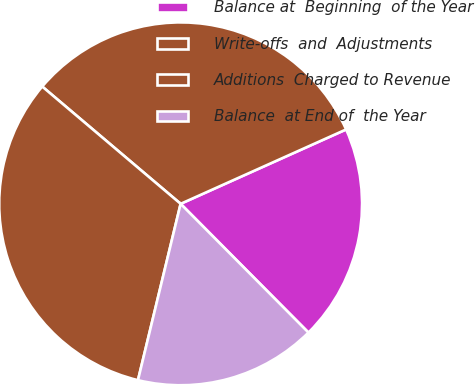Convert chart. <chart><loc_0><loc_0><loc_500><loc_500><pie_chart><fcel>Balance at  Beginning  of the Year<fcel>Write-offs  and  Adjustments<fcel>Additions  Charged to Revenue<fcel>Balance  at End of  the Year<nl><fcel>19.28%<fcel>32.09%<fcel>32.41%<fcel>16.22%<nl></chart> 